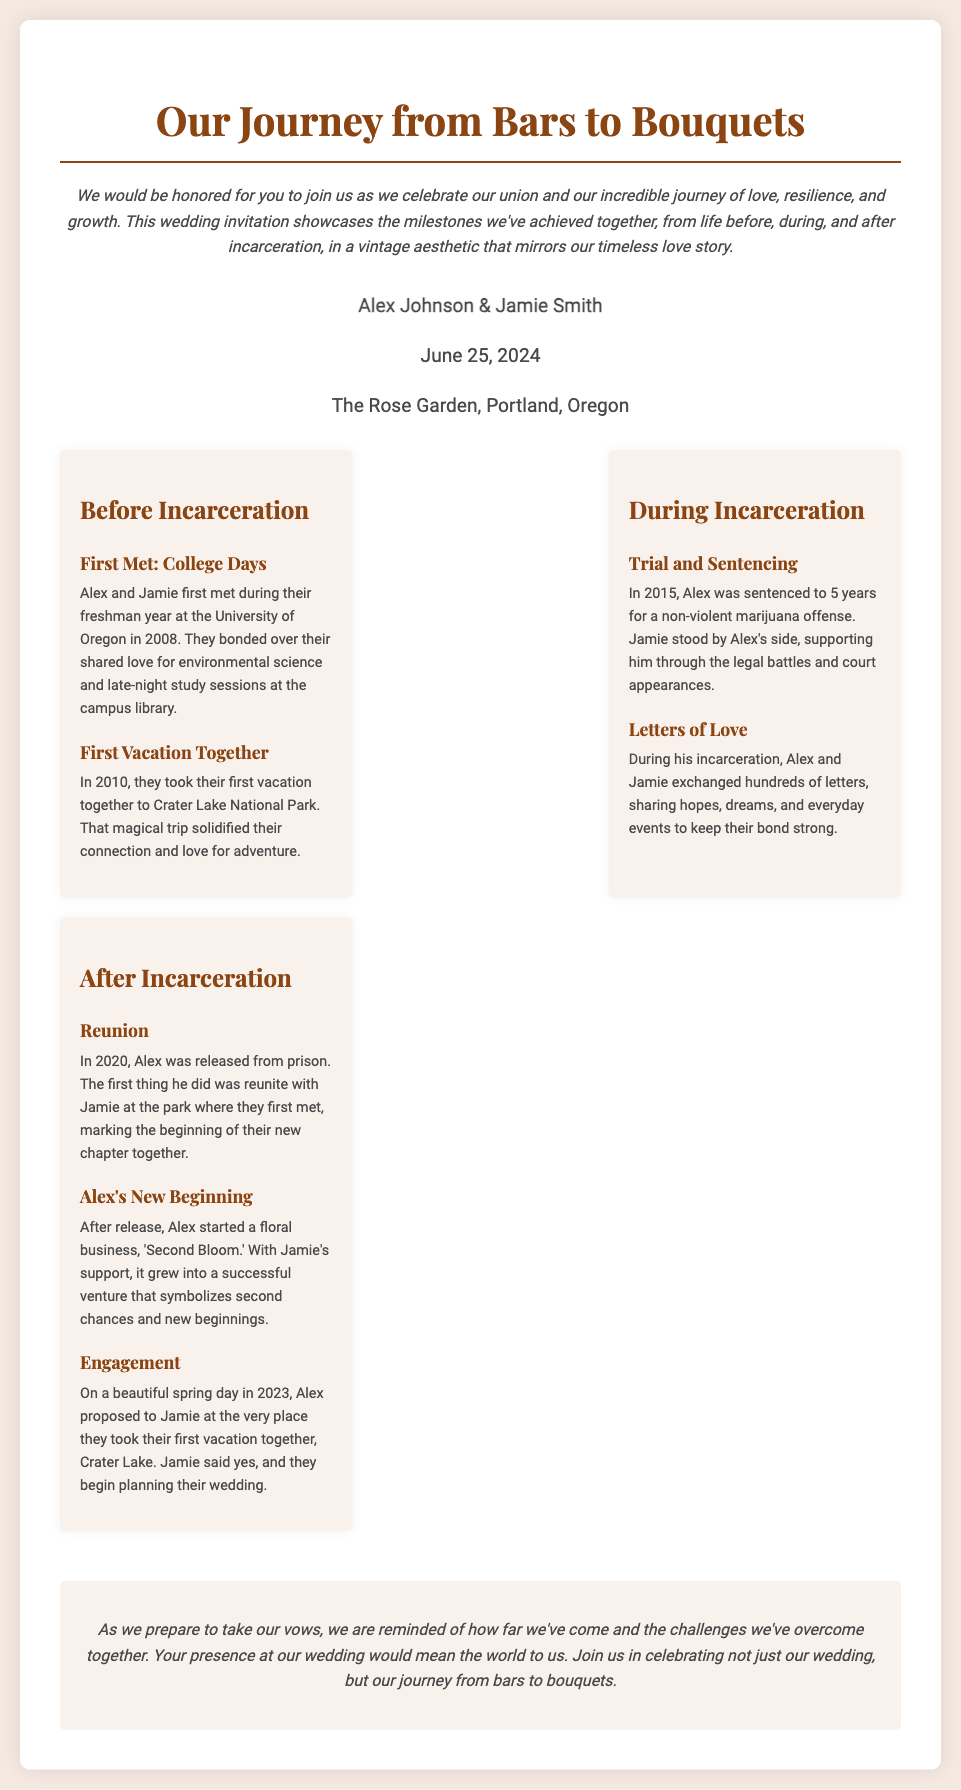What are the names of the couple? The couple's names are provided in the invitation as Alex Johnson and Jamie Smith.
Answer: Alex Johnson & Jamie Smith What is the date of the wedding? The wedding date is explicitly stated in the document.
Answer: June 25, 2024 Where is the wedding venue located? The document specifies the location of the wedding as The Rose Garden in Portland, Oregon.
Answer: The Rose Garden, Portland, Oregon What year was Alex sentenced? The document mentions the year Alex was sentenced during the "During Incarceration" section.
Answer: 2015 What type of business did Alex start after his release? The invitation details that Alex started a floral business named 'Second Bloom' after his release.
Answer: 'Second Bloom' What major event occurred in 2020? The document indicates the significant event of Alex’s release and reunion with Jamie in 2020.
Answer: Reunion How did Alex and Jamie keep their relationship strong during incarceration? The information provided shows that they exchanged letters frequently to maintain their bond.
Answer: Letters of Love What was the first vacation location of the couple? The document mentions that their first vacation was at Crater Lake National Park.
Answer: Crater Lake National Park What does the closing note emphasize about their journey? The closing note reflects on the couple's challenges and growth throughout their journey.
Answer: Growth 